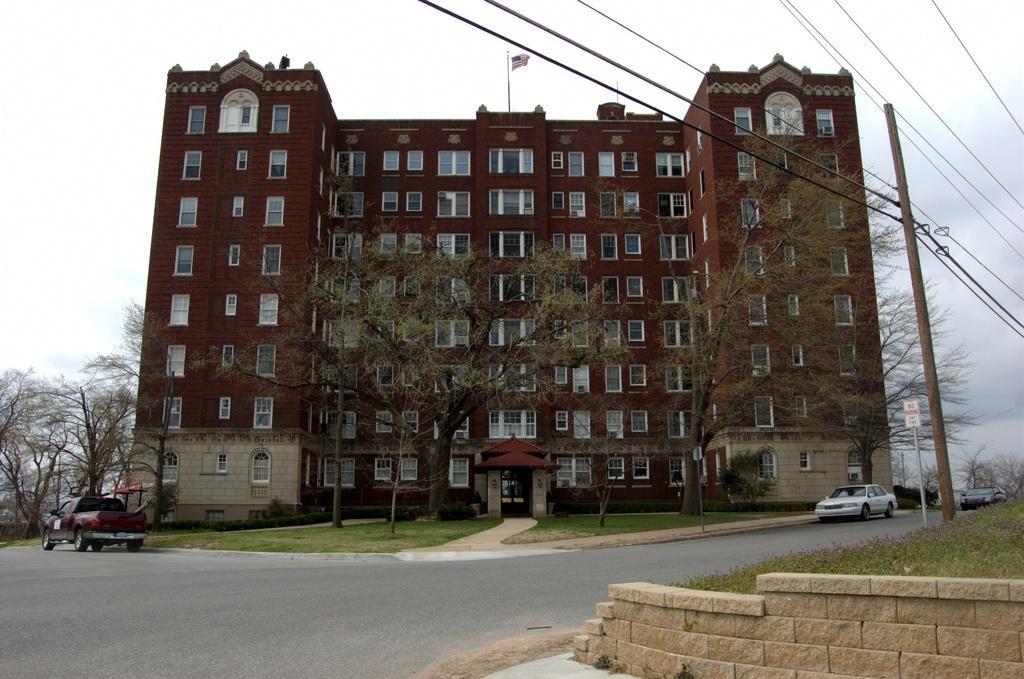Please provide a concise description of this image. This picture shows a building and we see trees and a wooden pole and couple of sign boards to the poles and we see cars moving on the road and few trees and a flagpole on the building and we see grass on the ground and a cloudy sky. 